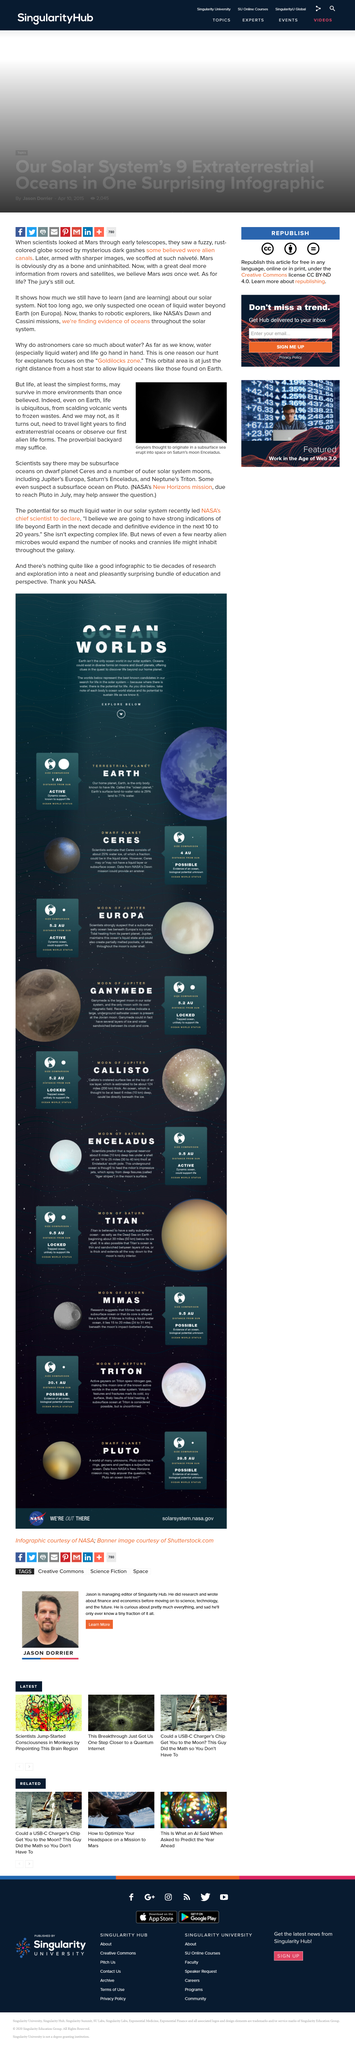Indicate a few pertinent items in this graphic. The geysers on Saturn's moon, Enceladus, are believed to have originated from a subsurface sea. Saturn has a moon named Enceladus. 